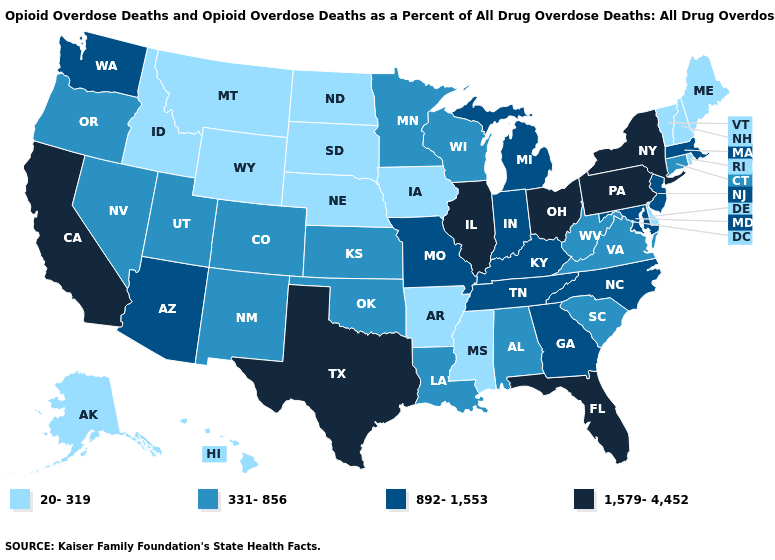What is the value of Alabama?
Quick response, please. 331-856. Does the first symbol in the legend represent the smallest category?
Be succinct. Yes. Name the states that have a value in the range 892-1,553?
Short answer required. Arizona, Georgia, Indiana, Kentucky, Maryland, Massachusetts, Michigan, Missouri, New Jersey, North Carolina, Tennessee, Washington. What is the value of West Virginia?
Quick response, please. 331-856. Does Massachusetts have a higher value than Alabama?
Short answer required. Yes. What is the value of Illinois?
Short answer required. 1,579-4,452. Name the states that have a value in the range 331-856?
Give a very brief answer. Alabama, Colorado, Connecticut, Kansas, Louisiana, Minnesota, Nevada, New Mexico, Oklahoma, Oregon, South Carolina, Utah, Virginia, West Virginia, Wisconsin. What is the value of New Hampshire?
Short answer required. 20-319. Among the states that border Colorado , which have the highest value?
Short answer required. Arizona. Which states have the lowest value in the West?
Write a very short answer. Alaska, Hawaii, Idaho, Montana, Wyoming. Name the states that have a value in the range 331-856?
Write a very short answer. Alabama, Colorado, Connecticut, Kansas, Louisiana, Minnesota, Nevada, New Mexico, Oklahoma, Oregon, South Carolina, Utah, Virginia, West Virginia, Wisconsin. Among the states that border Pennsylvania , which have the lowest value?
Short answer required. Delaware. Name the states that have a value in the range 892-1,553?
Give a very brief answer. Arizona, Georgia, Indiana, Kentucky, Maryland, Massachusetts, Michigan, Missouri, New Jersey, North Carolina, Tennessee, Washington. What is the value of Nebraska?
Be succinct. 20-319. Among the states that border Washington , does Idaho have the lowest value?
Give a very brief answer. Yes. 